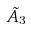Convert formula to latex. <formula><loc_0><loc_0><loc_500><loc_500>\tilde { A } _ { 3 }</formula> 